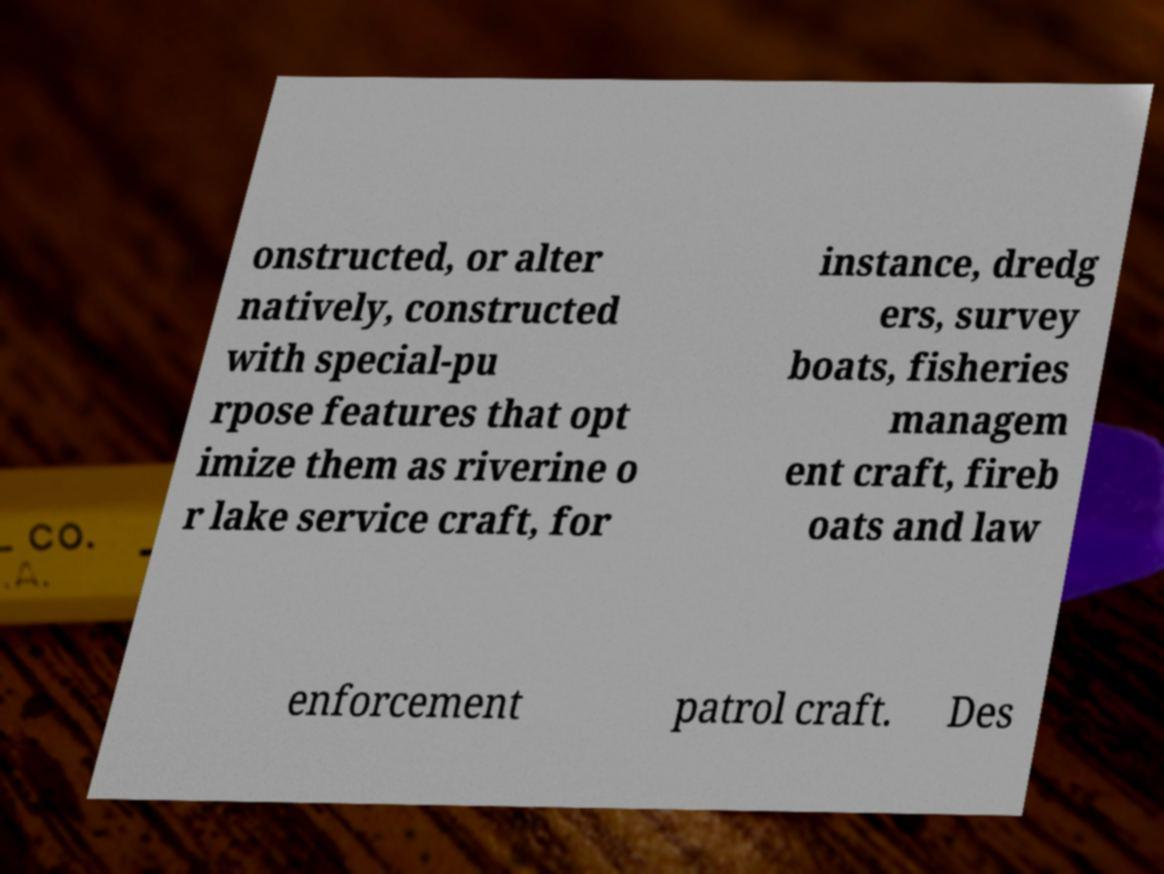I need the written content from this picture converted into text. Can you do that? onstructed, or alter natively, constructed with special-pu rpose features that opt imize them as riverine o r lake service craft, for instance, dredg ers, survey boats, fisheries managem ent craft, fireb oats and law enforcement patrol craft. Des 